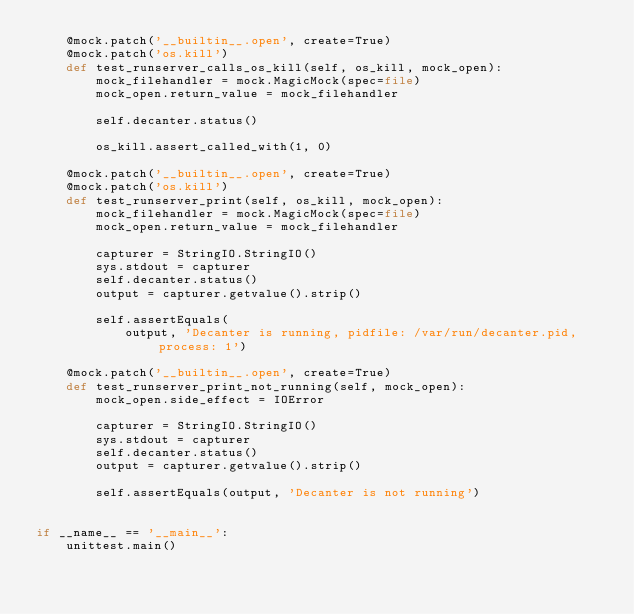<code> <loc_0><loc_0><loc_500><loc_500><_Python_>    @mock.patch('__builtin__.open', create=True)
    @mock.patch('os.kill')
    def test_runserver_calls_os_kill(self, os_kill, mock_open):
        mock_filehandler = mock.MagicMock(spec=file)
        mock_open.return_value = mock_filehandler

        self.decanter.status()

        os_kill.assert_called_with(1, 0)

    @mock.patch('__builtin__.open', create=True)
    @mock.patch('os.kill')
    def test_runserver_print(self, os_kill, mock_open):
        mock_filehandler = mock.MagicMock(spec=file)
        mock_open.return_value = mock_filehandler

        capturer = StringIO.StringIO()
        sys.stdout = capturer
        self.decanter.status()
        output = capturer.getvalue().strip()

        self.assertEquals(
            output, 'Decanter is running, pidfile: /var/run/decanter.pid, process: 1')

    @mock.patch('__builtin__.open', create=True)
    def test_runserver_print_not_running(self, mock_open):
        mock_open.side_effect = IOError

        capturer = StringIO.StringIO()
        sys.stdout = capturer
        self.decanter.status()
        output = capturer.getvalue().strip()

        self.assertEquals(output, 'Decanter is not running')


if __name__ == '__main__':
    unittest.main()
</code> 